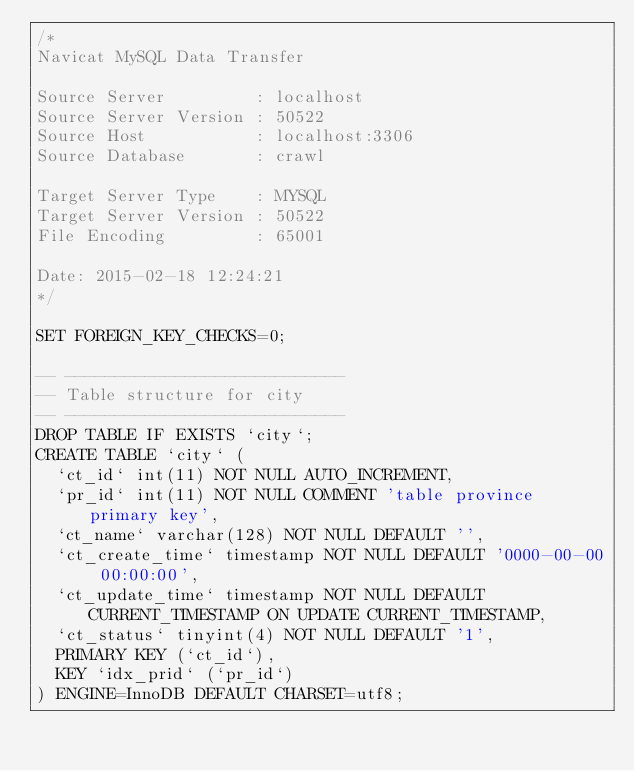<code> <loc_0><loc_0><loc_500><loc_500><_SQL_>/*
Navicat MySQL Data Transfer

Source Server         : localhost
Source Server Version : 50522
Source Host           : localhost:3306
Source Database       : crawl

Target Server Type    : MYSQL
Target Server Version : 50522
File Encoding         : 65001

Date: 2015-02-18 12:24:21
*/

SET FOREIGN_KEY_CHECKS=0;

-- ----------------------------
-- Table structure for city
-- ----------------------------
DROP TABLE IF EXISTS `city`;
CREATE TABLE `city` (
  `ct_id` int(11) NOT NULL AUTO_INCREMENT,
  `pr_id` int(11) NOT NULL COMMENT 'table province primary key',
  `ct_name` varchar(128) NOT NULL DEFAULT '',
  `ct_create_time` timestamp NOT NULL DEFAULT '0000-00-00 00:00:00',
  `ct_update_time` timestamp NOT NULL DEFAULT CURRENT_TIMESTAMP ON UPDATE CURRENT_TIMESTAMP,
  `ct_status` tinyint(4) NOT NULL DEFAULT '1',
  PRIMARY KEY (`ct_id`),
  KEY `idx_prid` (`pr_id`)
) ENGINE=InnoDB DEFAULT CHARSET=utf8;
</code> 